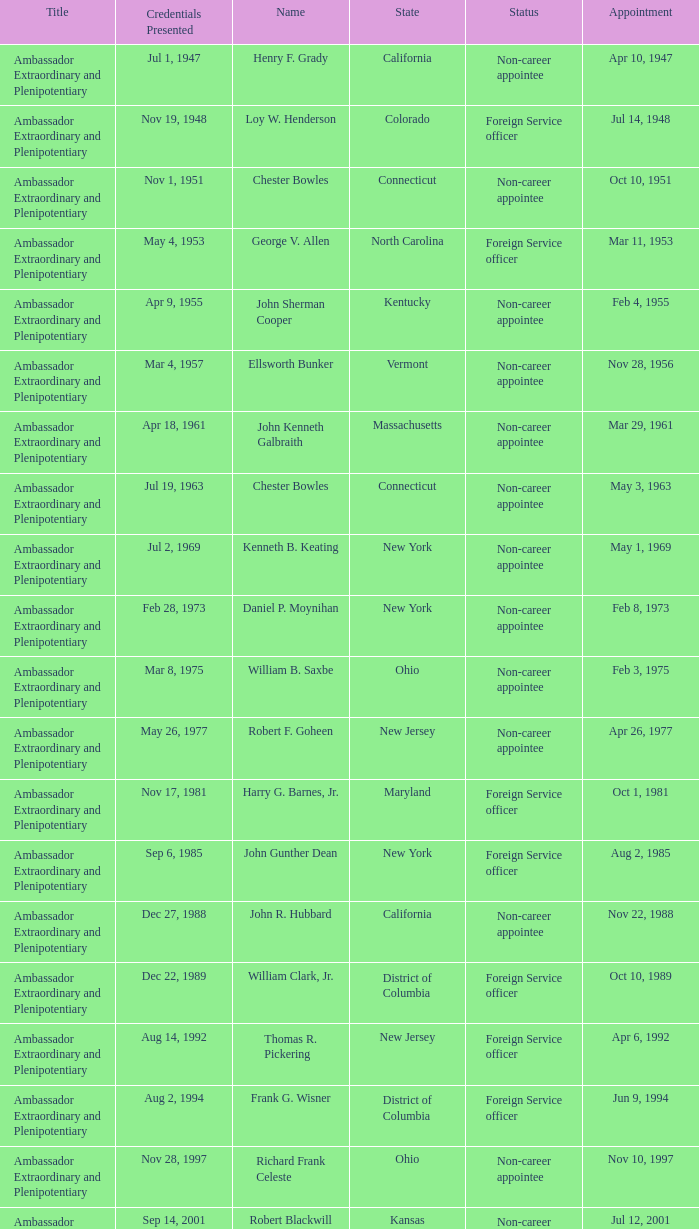What day was the appointment when Credentials Presented was jul 2, 1969? May 1, 1969. 